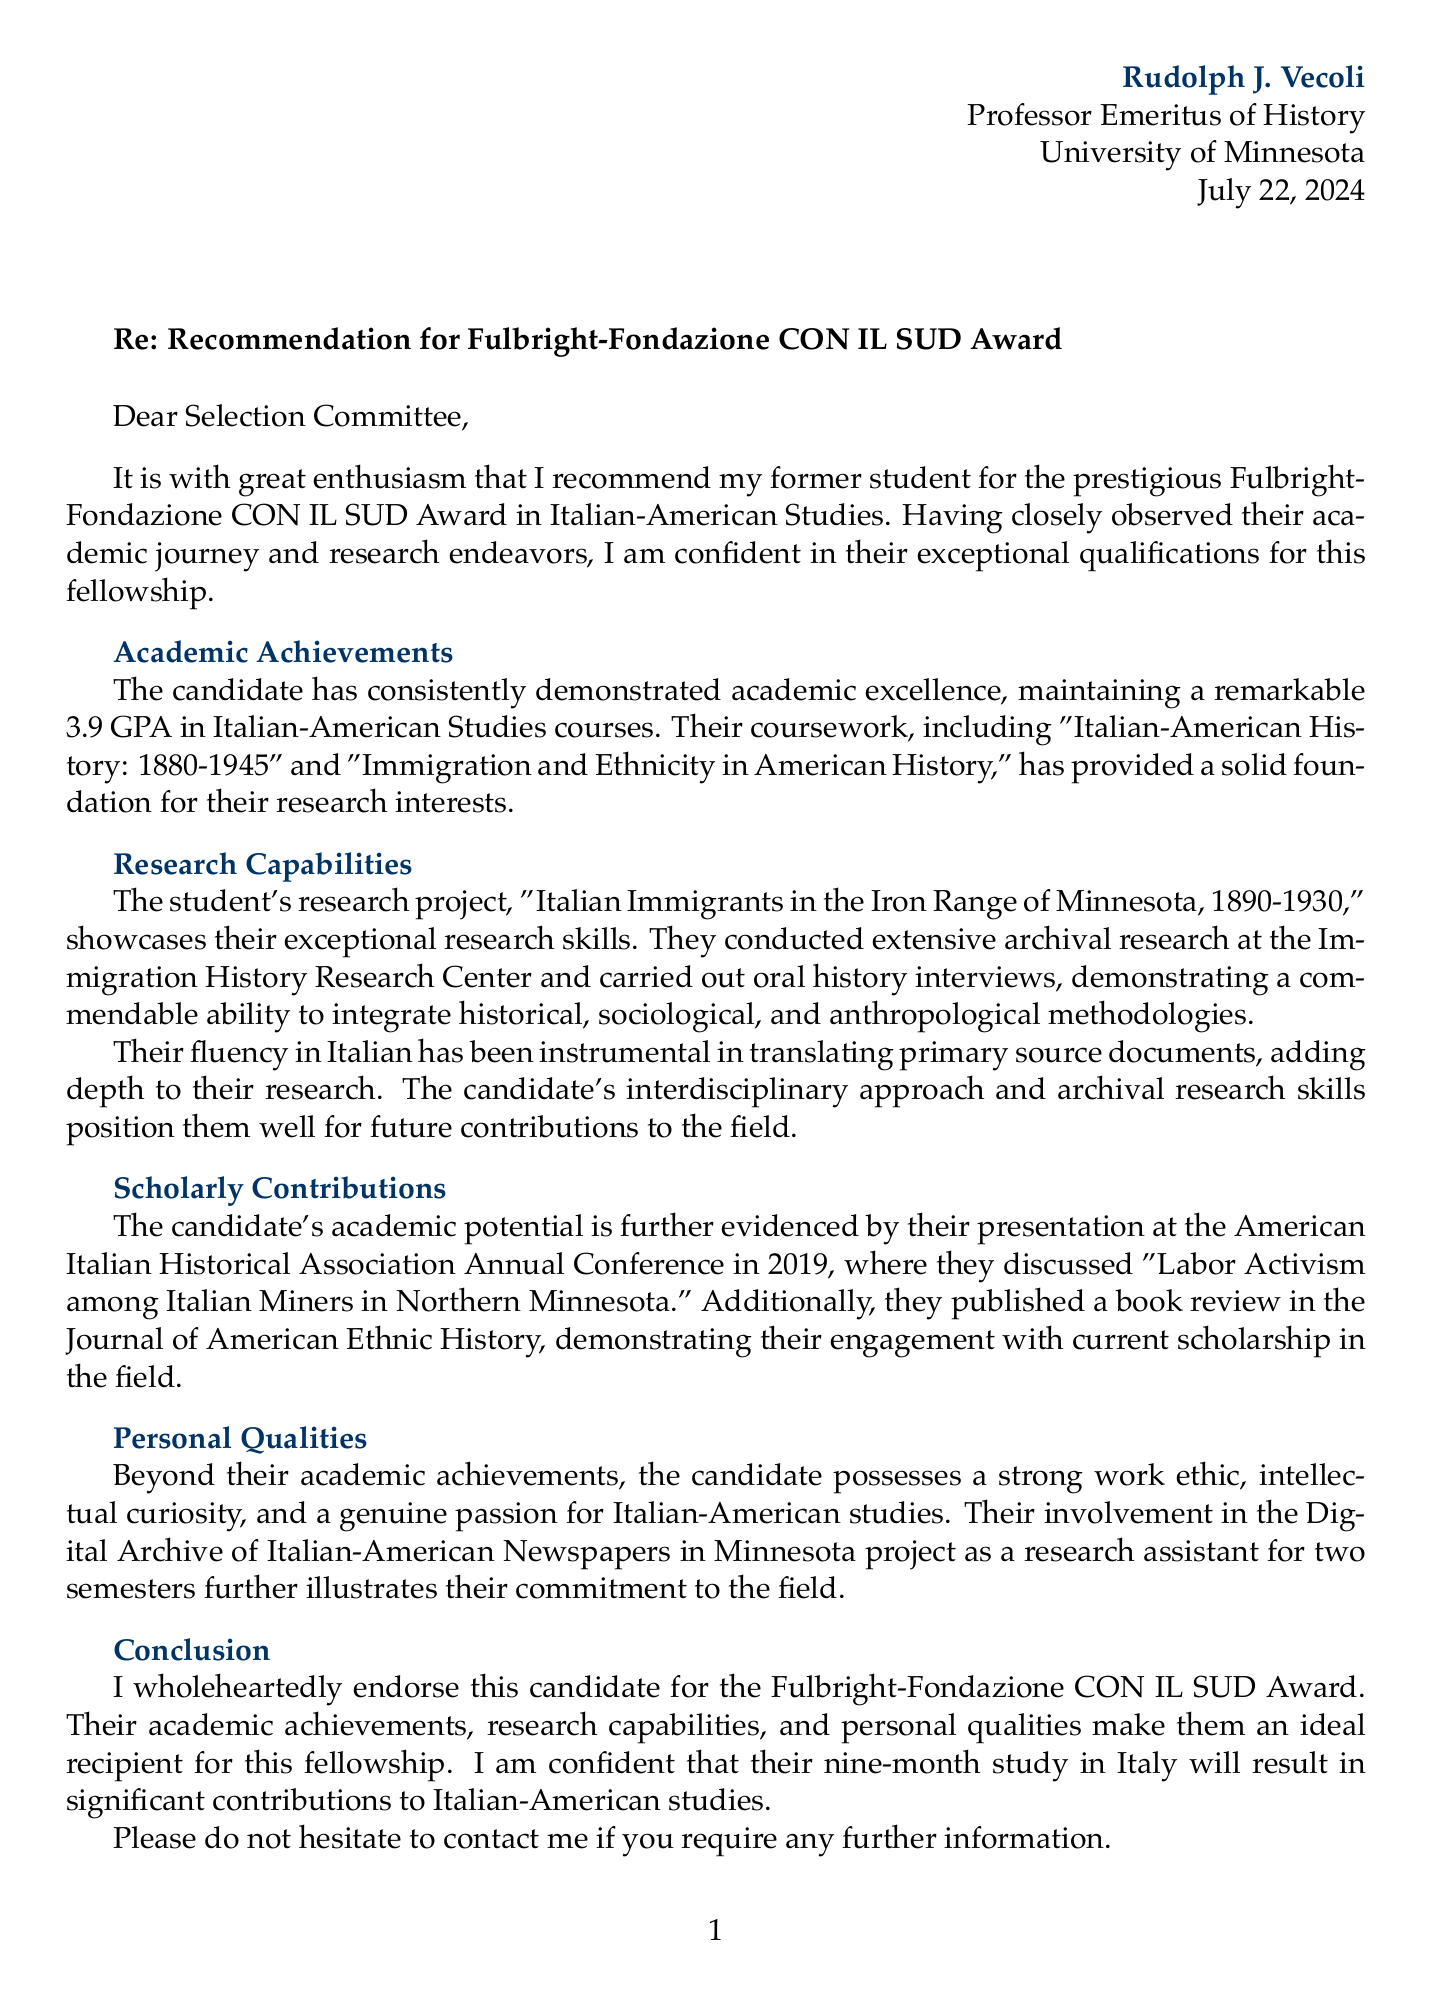What is the professor's name? The professor's name is stated at the beginning of the letter.
Answer: Rudolph J. Vecoli What is the student's GPA? The student's academic performance is highlighted in the letter with a specific GPA value.
Answer: 3.9 Which fellowship is being recommended? The fellowship for which the recommendation is provided is named in the letter.
Answer: Fulbright-Fondazione CON IL SUD Award What year did the student present at the conference? The year of the conference presentation is mentioned under the conference details.
Answer: 2019 What research project is mentioned in the letter? The letter outlines a specific research project conducted by the student.
Answer: Italian Immigrants in the Iron Range of Minnesota, 1890-1930 What is the location of the fellowship? The letter specifies a particular location for the fellowship in the details.
Answer: Italy Which personal quality is emphasized in the letter? The personal qualities of the student are discussed, focusing on their unique attributes.
Answer: Work ethic How long is the fellowship duration? The duration of the fellowship is explicitly stated within the letter content.
Answer: 9 months What is one of the primary methodologies used by the student? The letter notes the research methodologies that the student has effectively integrated.
Answer: Archival Research 